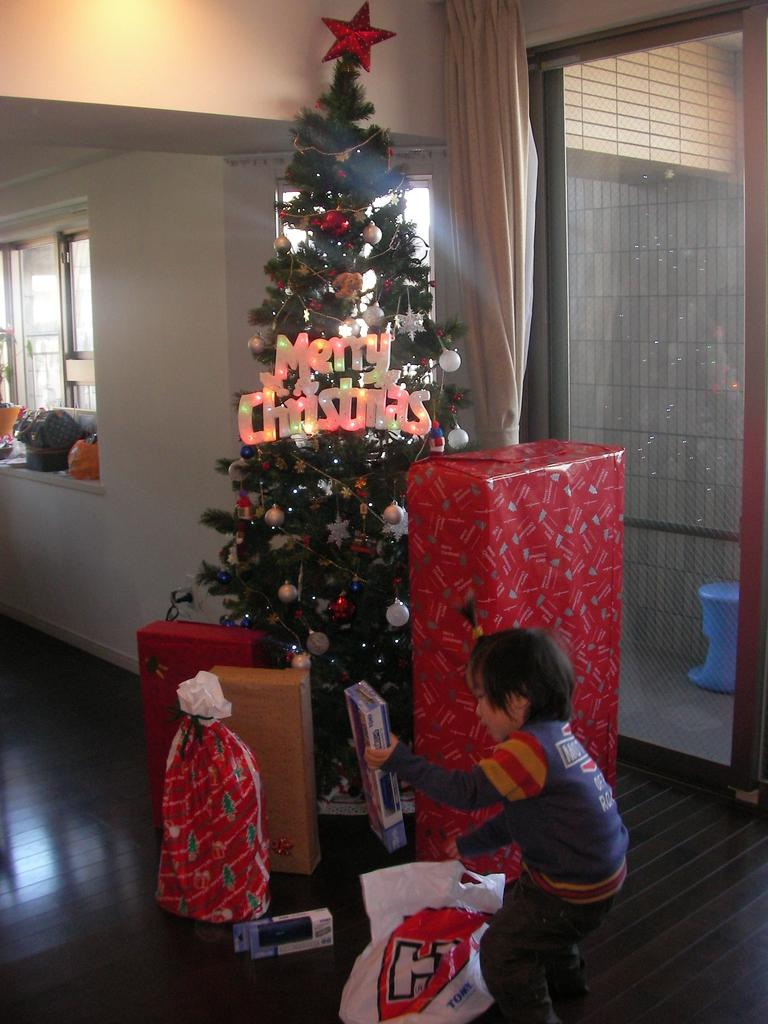<image>
Summarize the visual content of the image. A young boy holds a box in front of a Christmas tree that says Merry Christmas. 